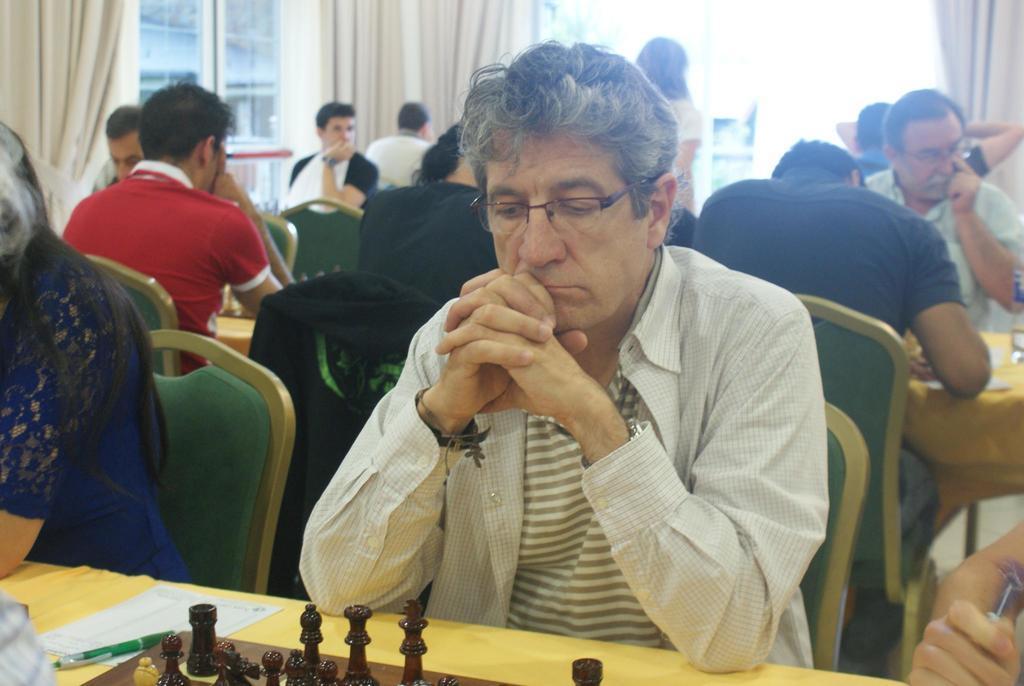Could you give a brief overview of what you see in this image? In this image I see number of people who are sitting on chairs and there are lot of tables in front of them, on which there are papers, pens, chess board and coins on it. In the background I see the windows and the curtains. 